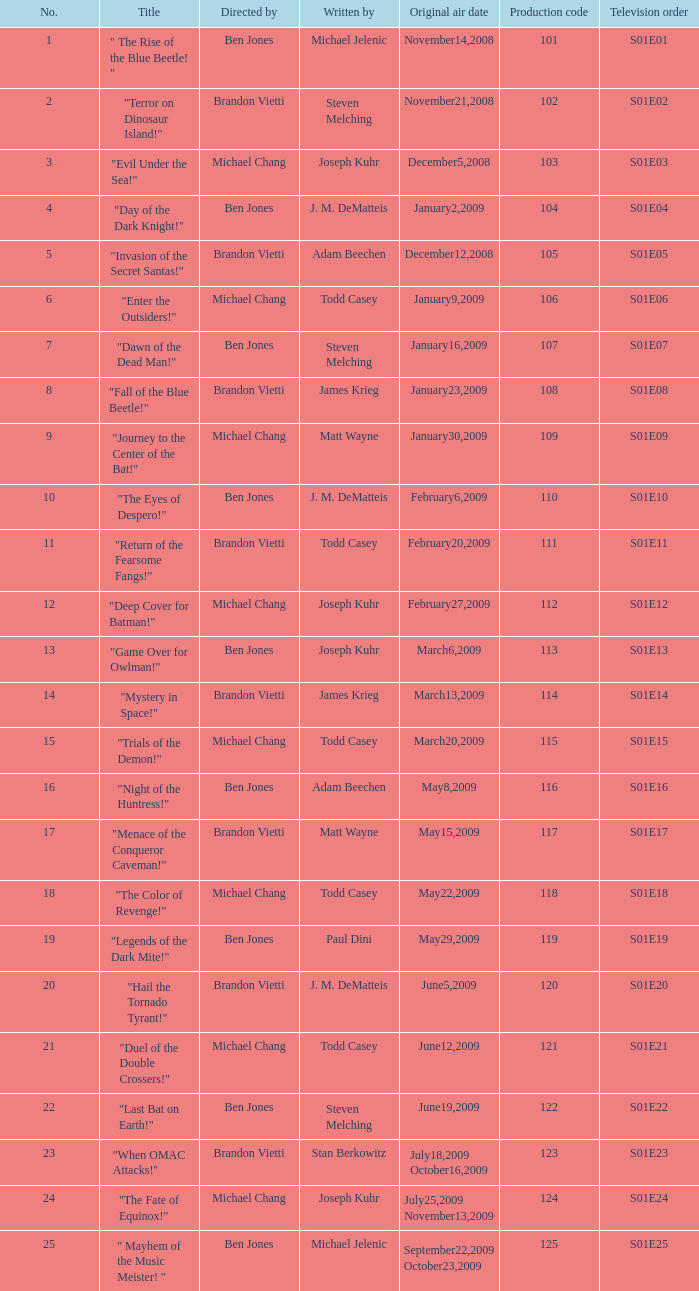In what order does the episode directed by ben jones, penned by j.m. dematteis, and initially aired on february 6, 2009, appear in the television series? S01E10. 